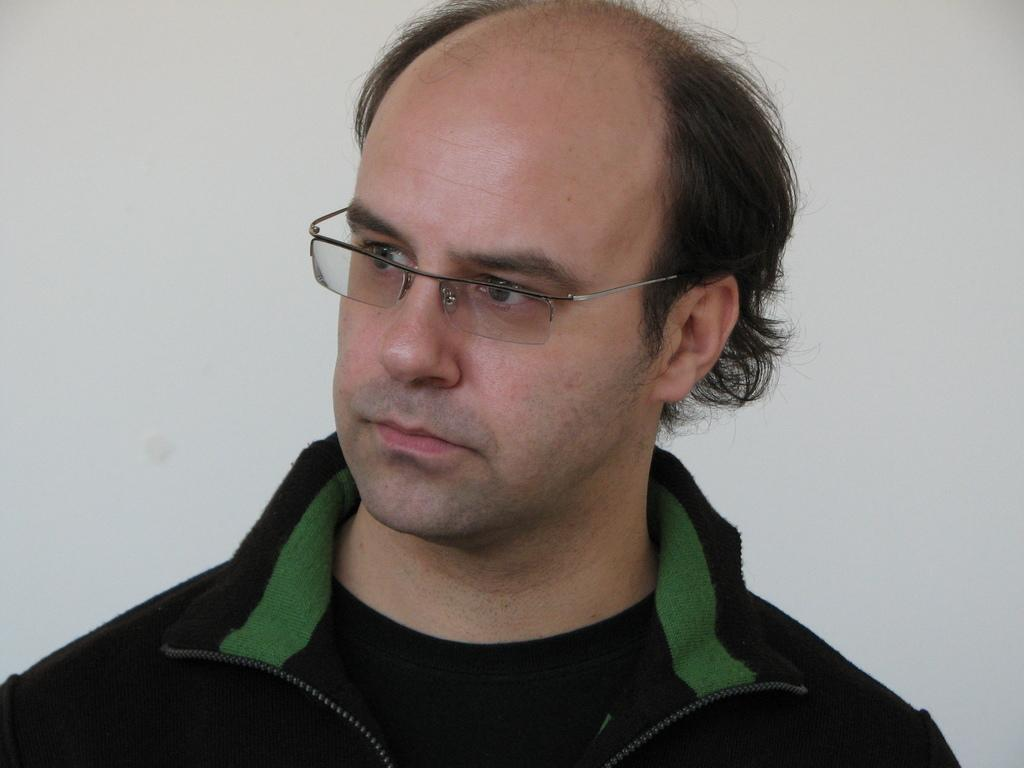What can be seen in the image? There is a person in the image. What is the person wearing? The person is wearing a black color jacket. What is the person doing in the image? The person is watching something. What color is the background of the image? The background of the image is white in color. What type of linen is being used to cover the event in the image? There is no event or linen present in the image; it features a person wearing a black color jacket and watching something against a white background. 